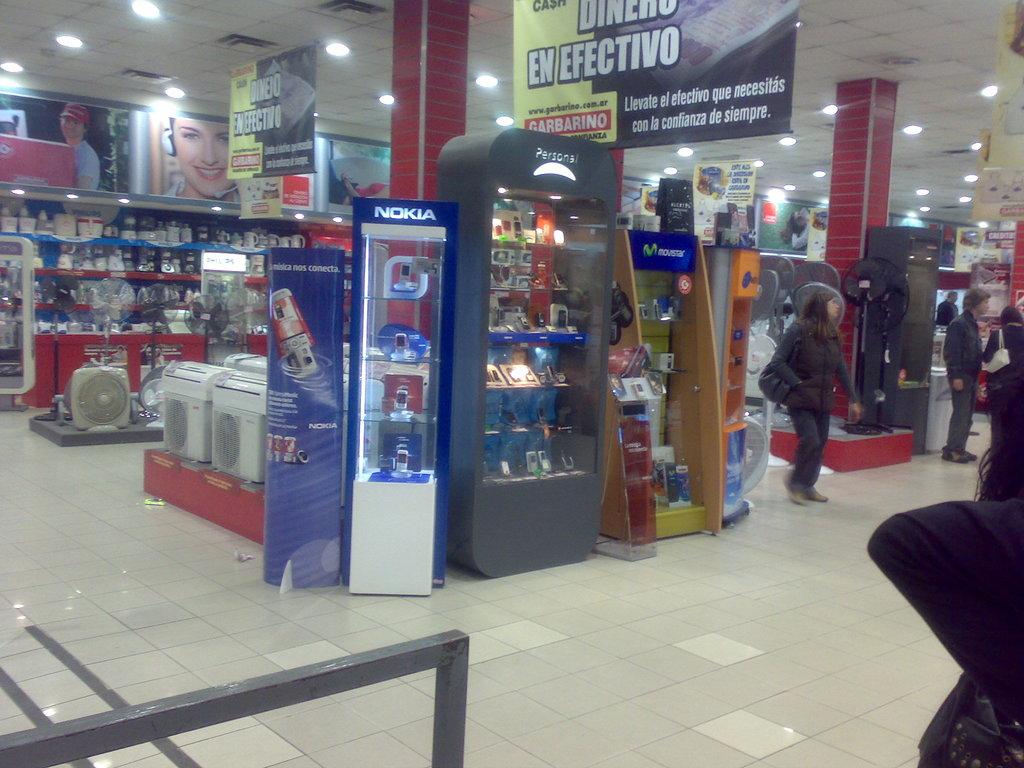What phone is in the case straight ahead?
Provide a short and direct response. Nokia. 